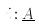<formula> <loc_0><loc_0><loc_500><loc_500>i \colon \underline { A }</formula> 